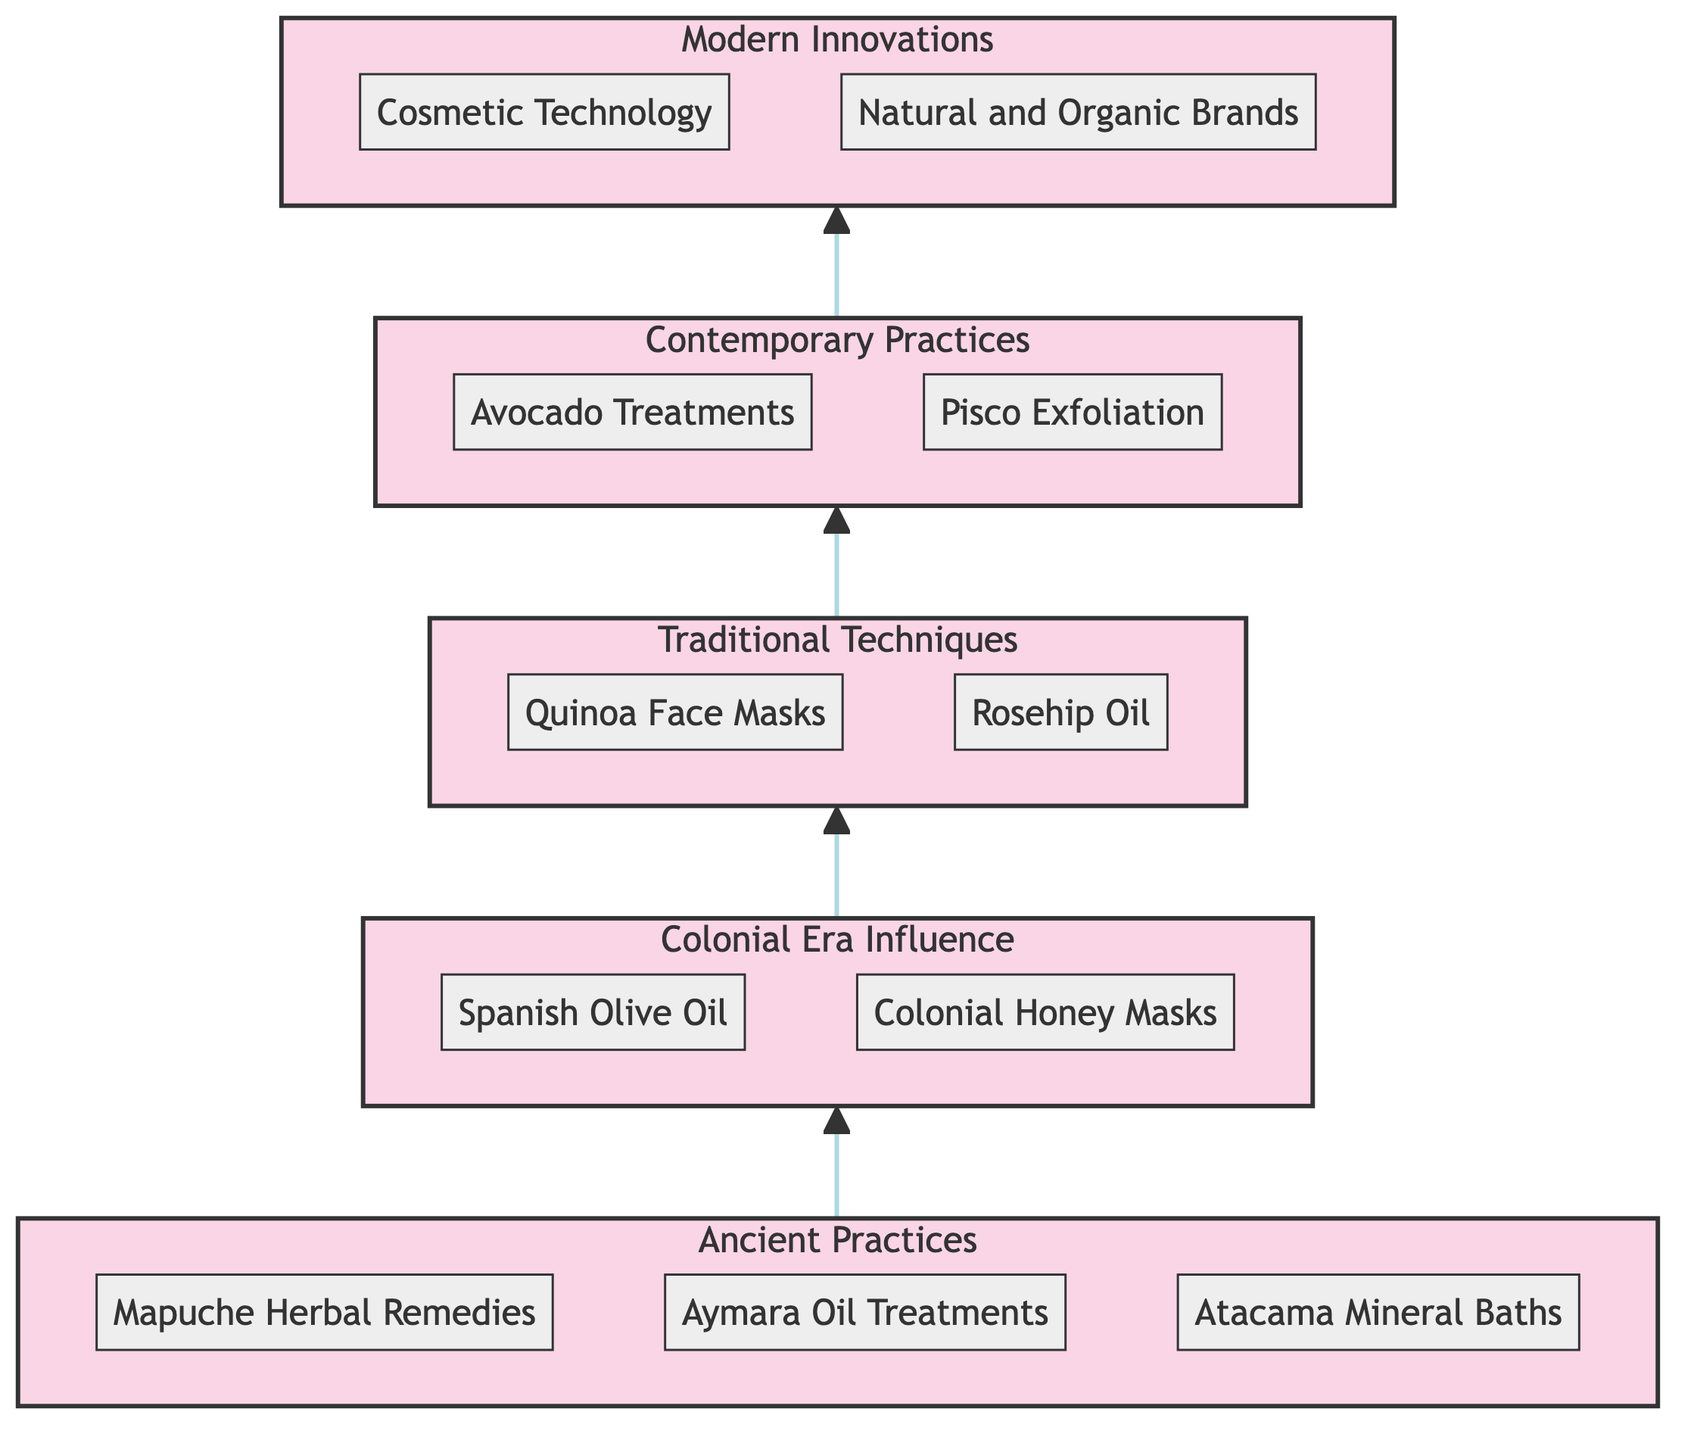What is the top stage in the flow chart? The flow chart clearly shows the stages, and the topmost stage is "Modern Innovations."
Answer: Modern Innovations How many stages are in the flow chart? Counting each labeled stage from bottom to top, there are five distinct stages presented in the flow chart.
Answer: 5 What element is at the second stage? The second stage is "Colonial Era Influence," which contains two elements: "Spanish Olive Oil" and "Colonial Honey Masks."
Answer: Spanish Olive Oil Which element relates to anti-aging properties? Among the elements listed, "Rosehip Oil" is specifically mentioned for its anti-aging properties.
Answer: Rosehip Oil What traditional technique uses quinoa? "Quinoa Face Masks" is the traditional technique specifically mentioned for utilizing quinoa for skincare.
Answer: Quinoa Face Masks Identify the relationship between contemporary practices and modern innovations. The diagram indicates that "Contemporary Practices" directly lead to "Modern Innovations," showing a progression in beauty rituals.
Answer: Leads to Which stage introduces natural and organic brands? The element "Natural and Organic Brands" is introduced in the "Modern Innovations" stage of the flow chart.
Answer: Modern Innovations What type of treatments are associated with the Atacama region? "Atacama Mineral Baths" connect with the ancient practices related to the Atacama region for mineral relaxation.
Answer: Atacama Mineral Baths What are the two elements in the contemporary practices stage? In the "Contemporary Practices" stage, the two elements mentioned are "Avocado Treatments" and "Pisco Exfoliation."
Answer: Avocado Treatments and Pisco Exfoliation 